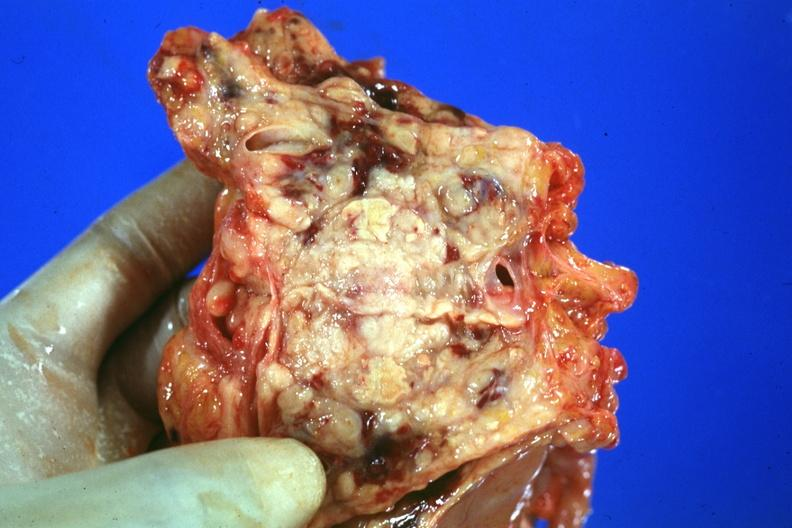s adenocarcinoma present?
Answer the question using a single word or phrase. Yes 